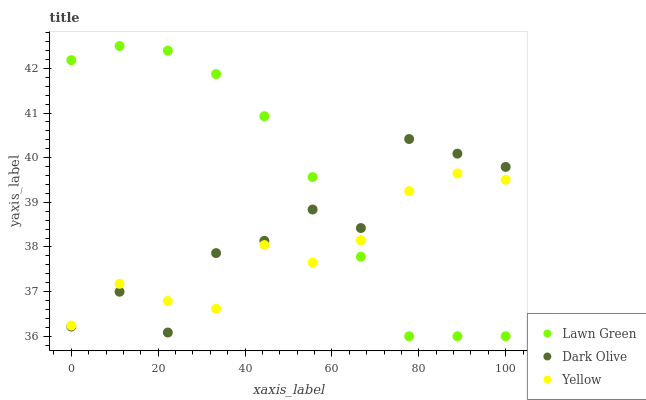Does Yellow have the minimum area under the curve?
Answer yes or no. Yes. Does Lawn Green have the maximum area under the curve?
Answer yes or no. Yes. Does Dark Olive have the minimum area under the curve?
Answer yes or no. No. Does Dark Olive have the maximum area under the curve?
Answer yes or no. No. Is Lawn Green the smoothest?
Answer yes or no. Yes. Is Dark Olive the roughest?
Answer yes or no. Yes. Is Yellow the smoothest?
Answer yes or no. No. Is Yellow the roughest?
Answer yes or no. No. Does Lawn Green have the lowest value?
Answer yes or no. Yes. Does Dark Olive have the lowest value?
Answer yes or no. No. Does Lawn Green have the highest value?
Answer yes or no. Yes. Does Dark Olive have the highest value?
Answer yes or no. No. Does Lawn Green intersect Dark Olive?
Answer yes or no. Yes. Is Lawn Green less than Dark Olive?
Answer yes or no. No. Is Lawn Green greater than Dark Olive?
Answer yes or no. No. 